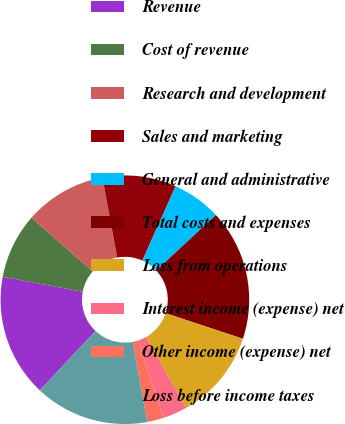<chart> <loc_0><loc_0><loc_500><loc_500><pie_chart><fcel>Revenue<fcel>Cost of revenue<fcel>Research and development<fcel>Sales and marketing<fcel>General and administrative<fcel>Total costs and expenses<fcel>Loss from operations<fcel>Interest income (expense) net<fcel>Other income (expense) net<fcel>Loss before income taxes<nl><fcel>15.96%<fcel>8.51%<fcel>10.64%<fcel>9.57%<fcel>6.38%<fcel>17.02%<fcel>11.7%<fcel>3.19%<fcel>2.13%<fcel>14.89%<nl></chart> 